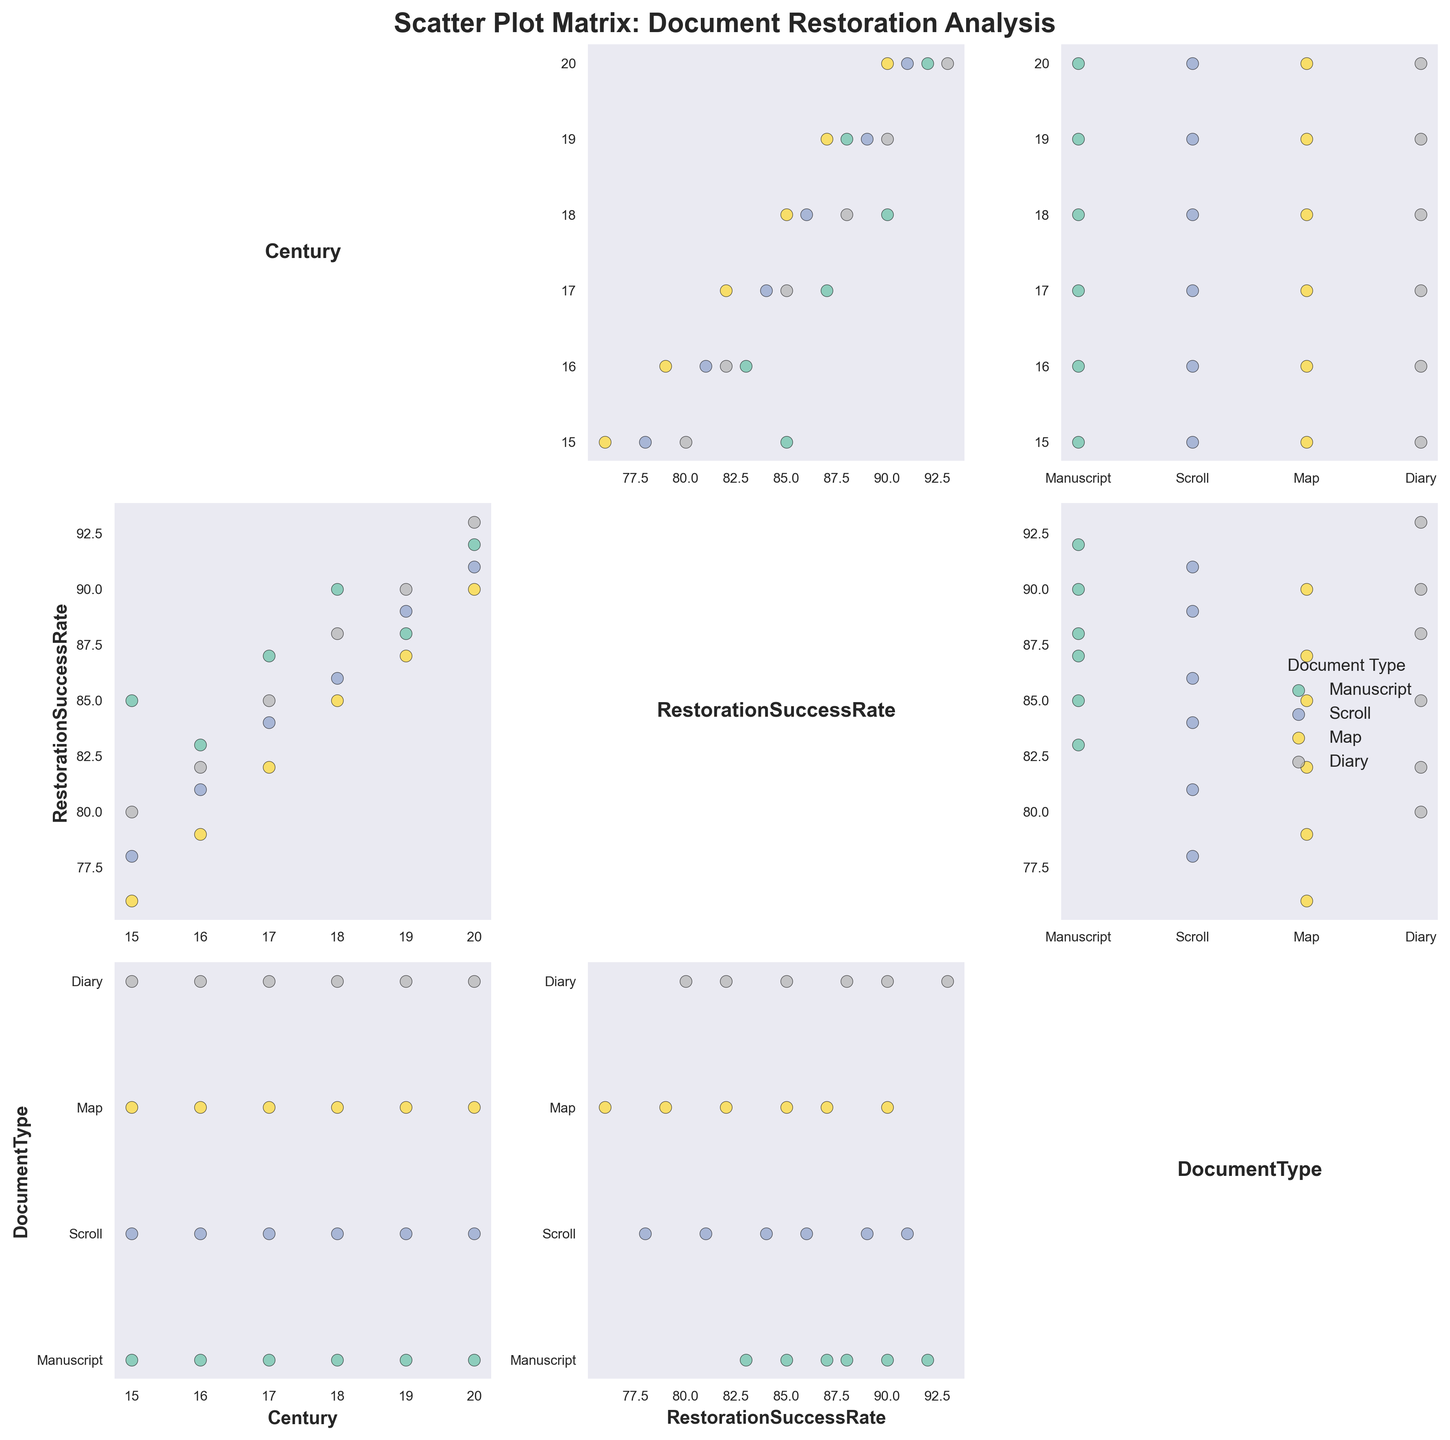What is the title of the SPLOM? The title of the SPLOM is mentioned at the top of the figure. It reads 'Scatter Plot Matrix: Document Restoration Analysis'.
Answer: Scatter Plot Matrix: Document Restoration Analysis How many document types are compared in this figure? The legend shows four distinct colors, each representing a different document type.
Answer: Four Which century shows the highest restoration success rate overall? By looking at the 'Century' vs. 'RestorationSuccessRate' plots, the 20th century consistently shows the highest success rates across all document types.
Answer: 20th century Do Manuscripts have a higher average restoration success rate than Maps? First, determine the average restoration success rates for Manuscripts and Maps across all centuries. Manuscripts have rates of 85, 83, 87, 90, 88, 92. Maps have rates of 76, 79, 82, 85, 87, 90. Calculate their averages and compare. Manuscripts: (85+83+87+90+88+92)/6 = 87.5; Maps: (76+79+82+85+87+90)/6 = 83.17. Hence, Manuscripts have a higher average restoration success rate.
Answer: Yes Which document type shows the smallest spread in restoration success rates across centuries? Look at the range (difference between maximum and minimum values) of restoration success rates for each document type. Maps have rates between 76 and 90 (spread = 14), Manuscripts between 83 and 92 (spread = 9), Diaries between 80 and 93 (spread = 13), and Scrolls between 78 and 91 (spread = 13). Therefore, Manuscripts show the smallest spread.
Answer: Manuscripts In which century do Scrolls start to show a higher success rate than Manuscripts? Compare the 'Restoration Success Rates' of Scrolls and Manuscripts across centuries. Scrolls surpass Manuscripts beginning in the 17th century where Scrolls have an 84 and Manuscripts have an 83.
Answer: 17th century Is there a century where all document types have similar restoration success rates? Observe the scatter plots to identify any century where the data points for all document types cluster closely together around the same success rate. Around the 19th century, restoration success rates are close together: Manuscripts (88), Scrolls (89), Maps (87), and Diaries (90).
Answer: 19th century Which scatter plot unit shows the most clustering or tightest spread between 'Century' and 'RestorationSuccessRate'? Examine the scatter plots for all document types and identify the one with the least spread. The 'Diary' scatter plots from the 18th and 19th centuries show the tightest clustering, suggesting minimal variation.
Answer: Diaries in the 18th and 19th centuries 